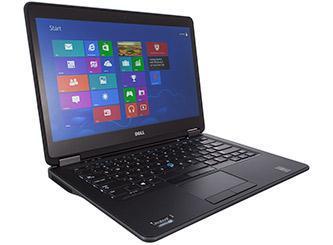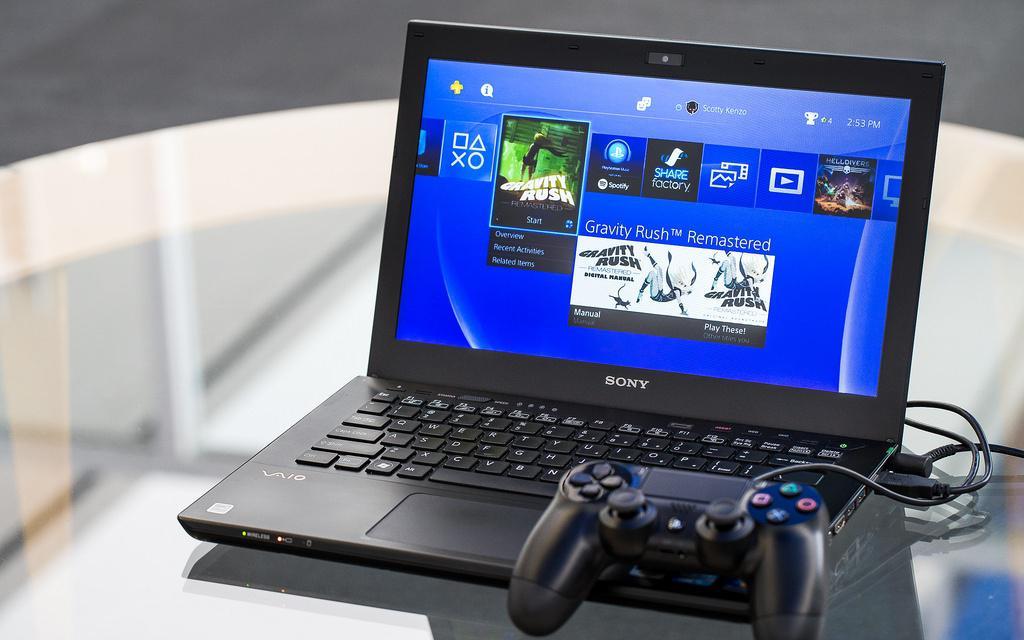The first image is the image on the left, the second image is the image on the right. Considering the images on both sides, is "An image includes a laptop that is facing directly forward." valid? Answer yes or no. No. The first image is the image on the left, the second image is the image on the right. Considering the images on both sides, is "A mouse is connected to the computer on the right." valid? Answer yes or no. No. 